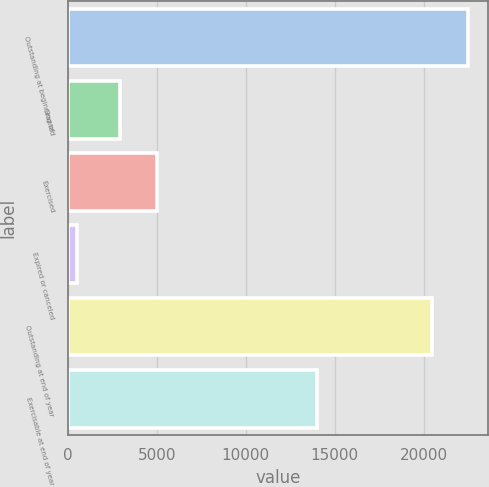<chart> <loc_0><loc_0><loc_500><loc_500><bar_chart><fcel>Outstanding at beginning of<fcel>Granted<fcel>Exercised<fcel>Expired or canceled<fcel>Outstanding at end of year<fcel>Exercisable at end of year<nl><fcel>22494<fcel>2953<fcel>5004<fcel>531<fcel>20443<fcel>14015<nl></chart> 